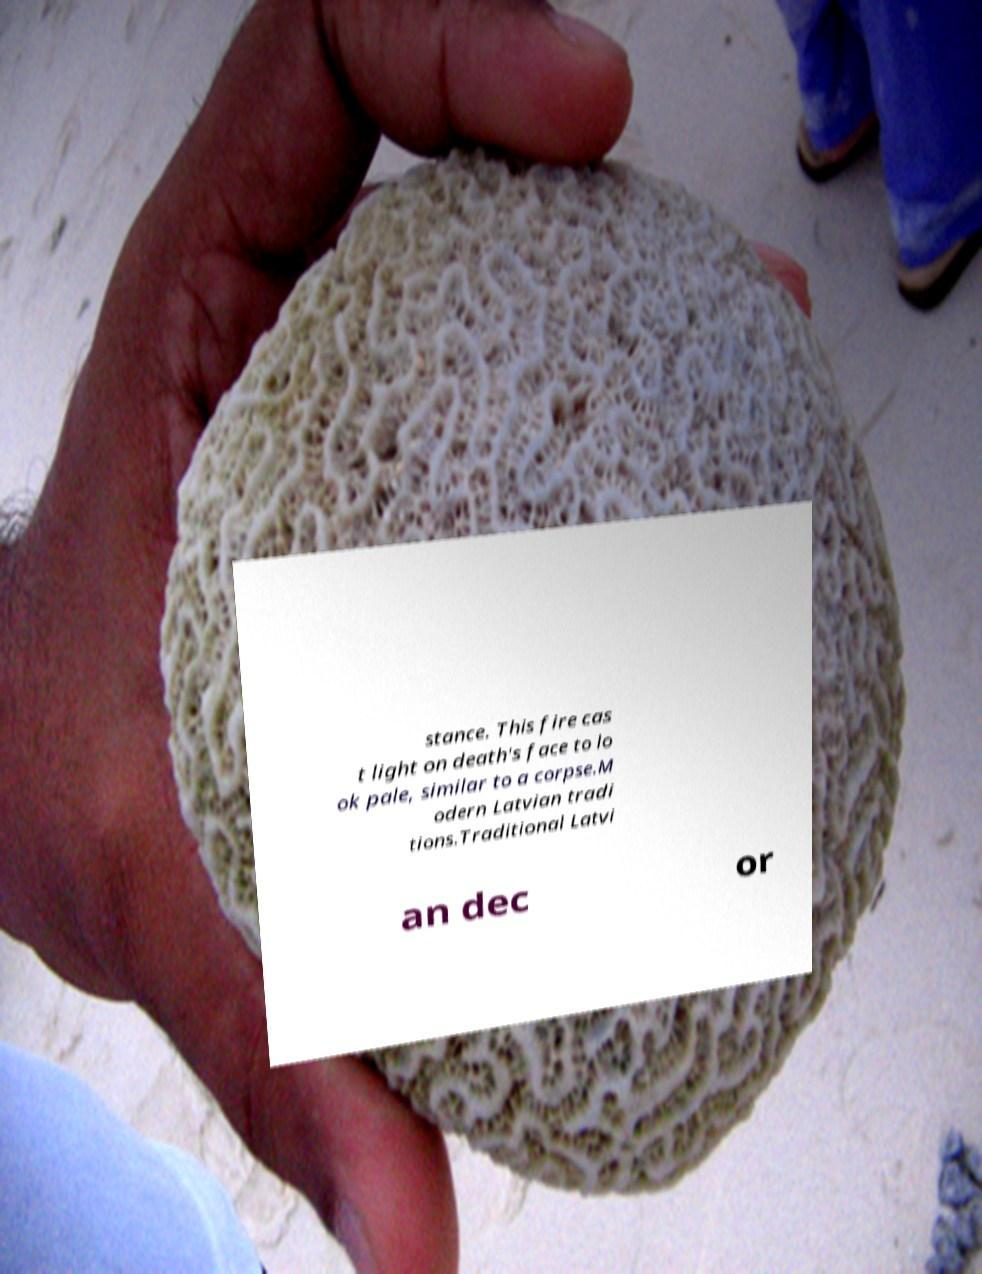I need the written content from this picture converted into text. Can you do that? stance. This fire cas t light on death's face to lo ok pale, similar to a corpse.M odern Latvian tradi tions.Traditional Latvi an dec or 